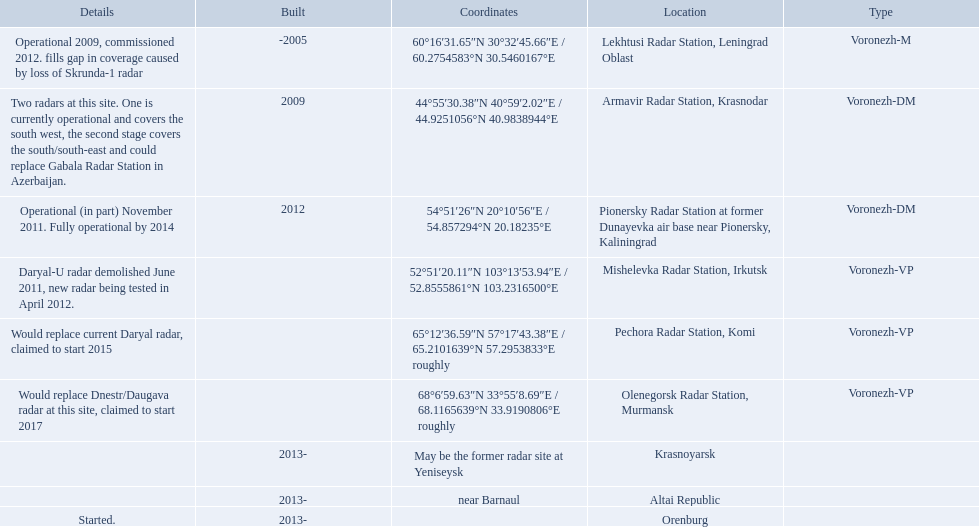Which voronezh radar has already started? Orenburg. Which radar would replace dnestr/daugava? Olenegorsk Radar Station, Murmansk. Which radar started in 2015? Pechora Radar Station, Komi. 